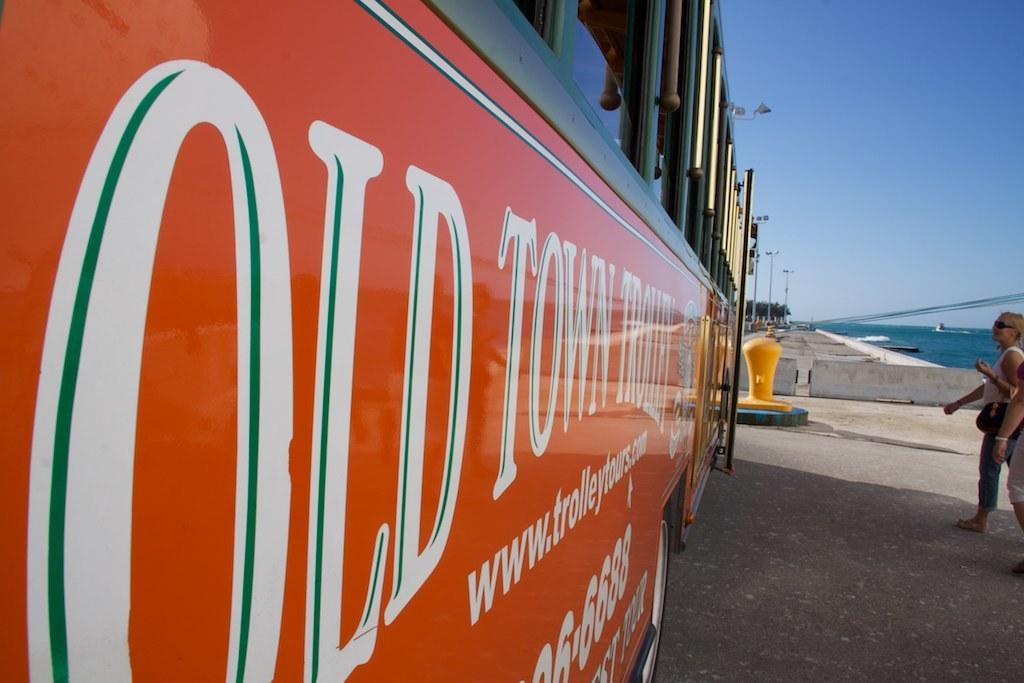<image>
Summarize the visual content of the image. A sign on a trolley that has the website www.trolleytours.com on it. 